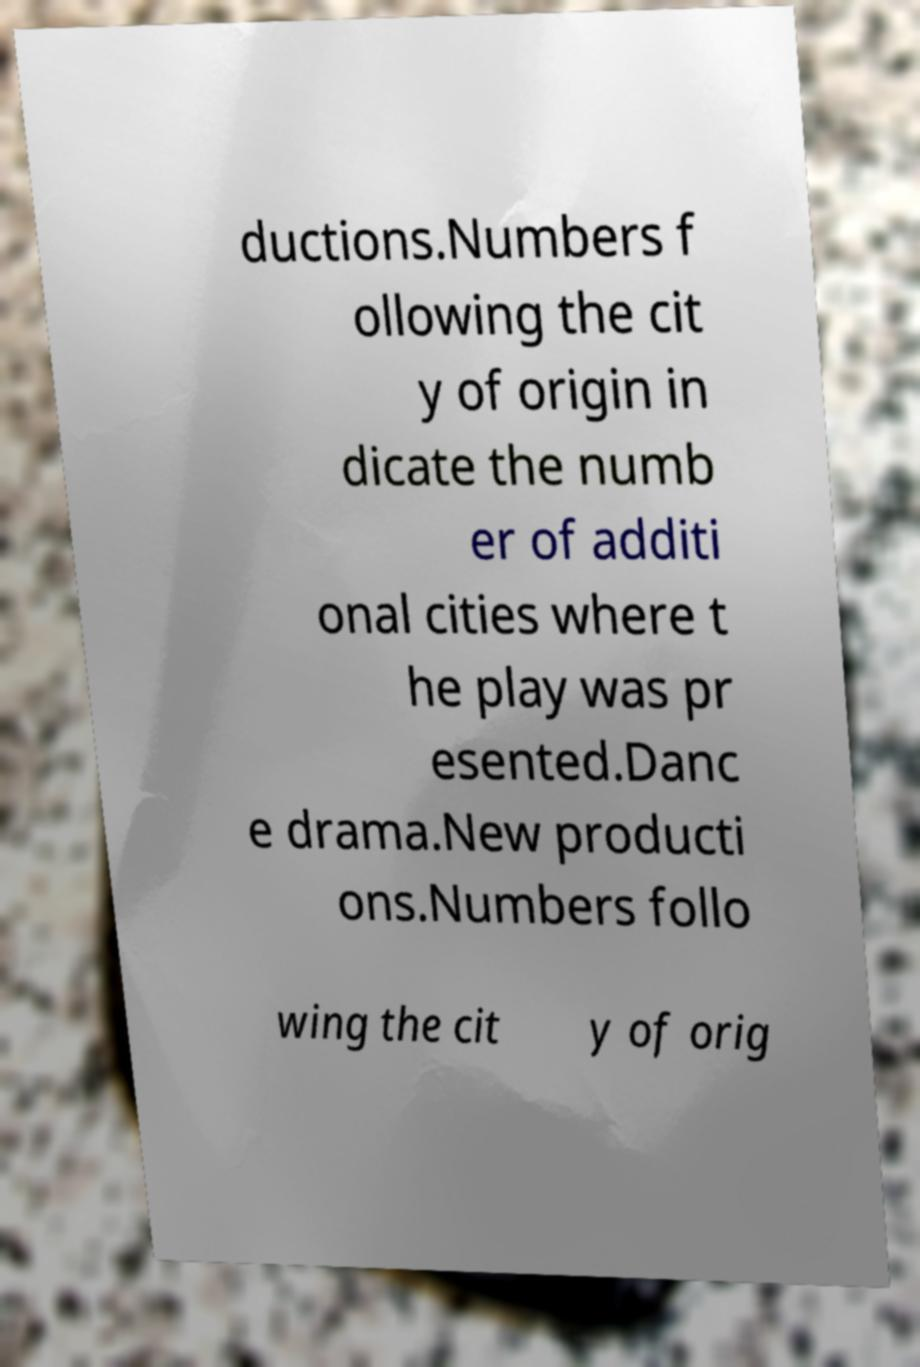There's text embedded in this image that I need extracted. Can you transcribe it verbatim? ductions.Numbers f ollowing the cit y of origin in dicate the numb er of additi onal cities where t he play was pr esented.Danc e drama.New producti ons.Numbers follo wing the cit y of orig 